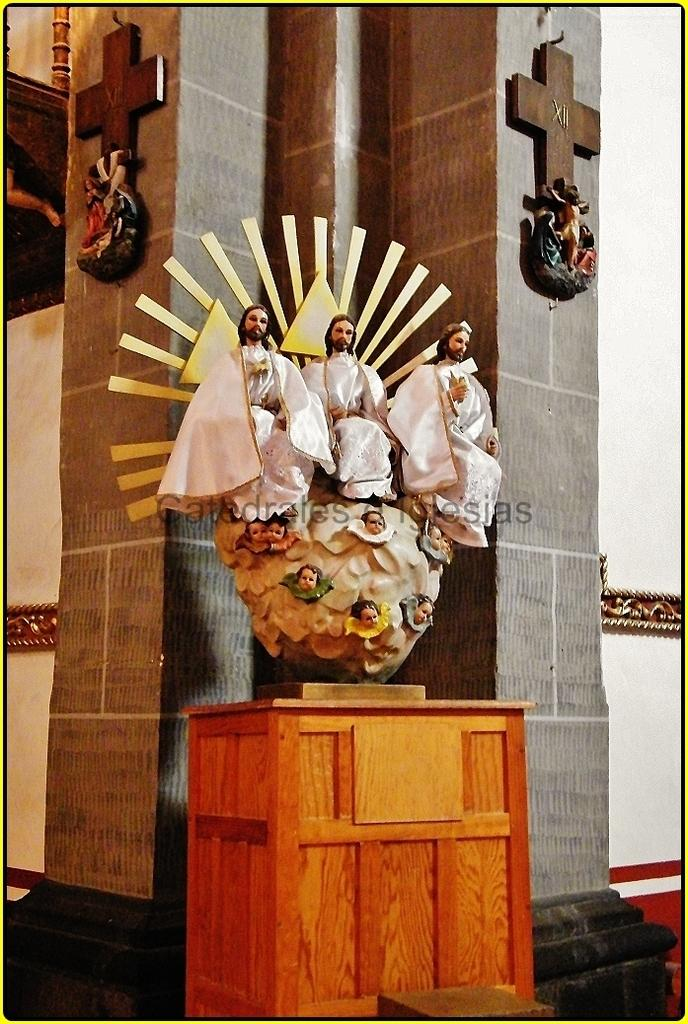What type of art is present in the image? There are sculptures in the image. What color are the sculptures dressed in? The sculptures are dressed in white color. Can you describe any other objects in the image? There is a brown-colored object in the image. What type of stitch is used to create the sculptures in the image? The sculptures are not made using stitching; they are likely made of a solid material like stone or metal. How does the image convey a sense of good-bye? The image does not convey a sense of good-bye; it simply depicts sculptures and a brown-colored object. 